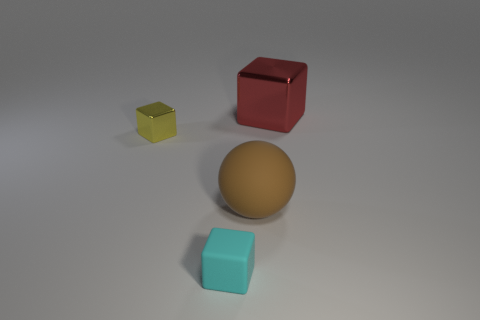What number of other objects are there of the same material as the cyan block?
Offer a terse response. 1. What shape is the metal object that is behind the tiny yellow metal thing in front of the shiny block behind the yellow cube?
Offer a terse response. Cube. Are there fewer big balls that are to the left of the yellow metallic object than small metal objects in front of the big red shiny thing?
Keep it short and to the point. Yes. Does the tiny yellow block have the same material as the thing that is behind the small yellow shiny cube?
Make the answer very short. Yes. Are there any big red objects that are right of the metal cube in front of the large block?
Keep it short and to the point. Yes. What is the color of the object that is on the right side of the yellow thing and behind the brown rubber ball?
Your response must be concise. Red. What size is the cyan cube?
Your response must be concise. Small. What number of yellow cubes have the same size as the ball?
Keep it short and to the point. 0. Is the small block in front of the brown sphere made of the same material as the block behind the tiny metallic thing?
Give a very brief answer. No. There is a large thing that is in front of the metal block left of the brown matte object; what is it made of?
Offer a terse response. Rubber. 